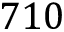Convert formula to latex. <formula><loc_0><loc_0><loc_500><loc_500>7 1 0</formula> 